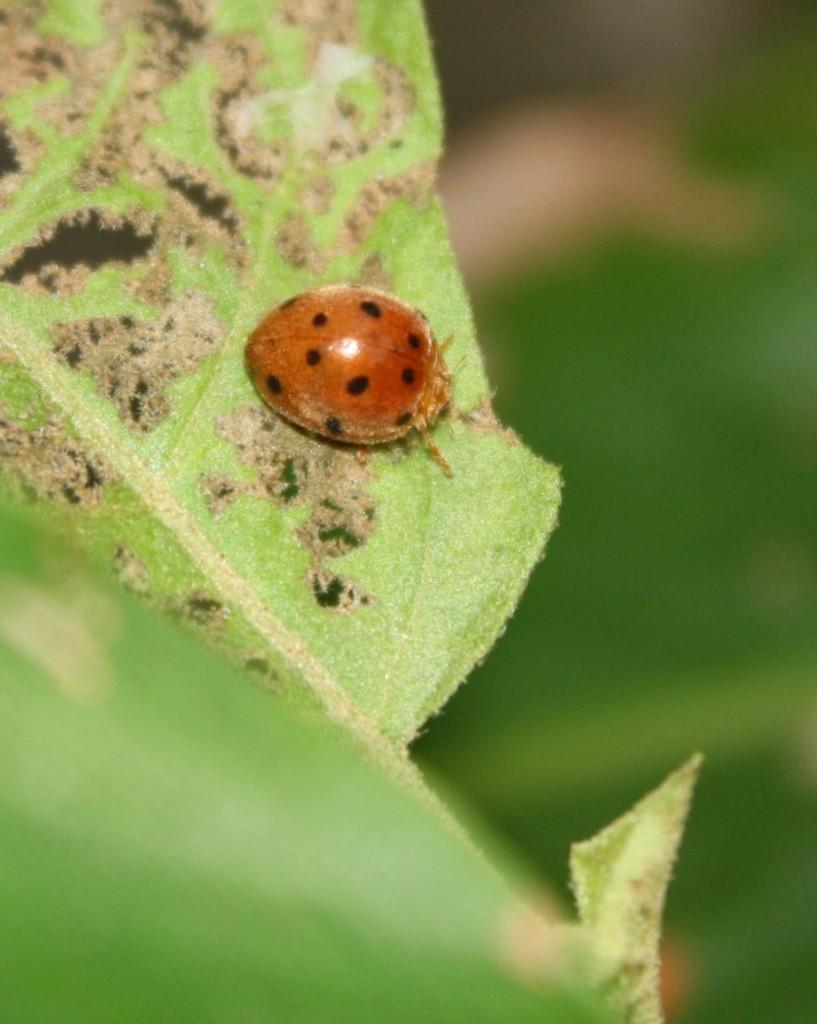What is present on the leaf in the image? There is an insect on a leaf in the image. Can you describe the background of the image? The background of the image is blurry. What type of iron can be seen in the image? There is no iron present in the image; it features an insect on a leaf with a blurry background. 